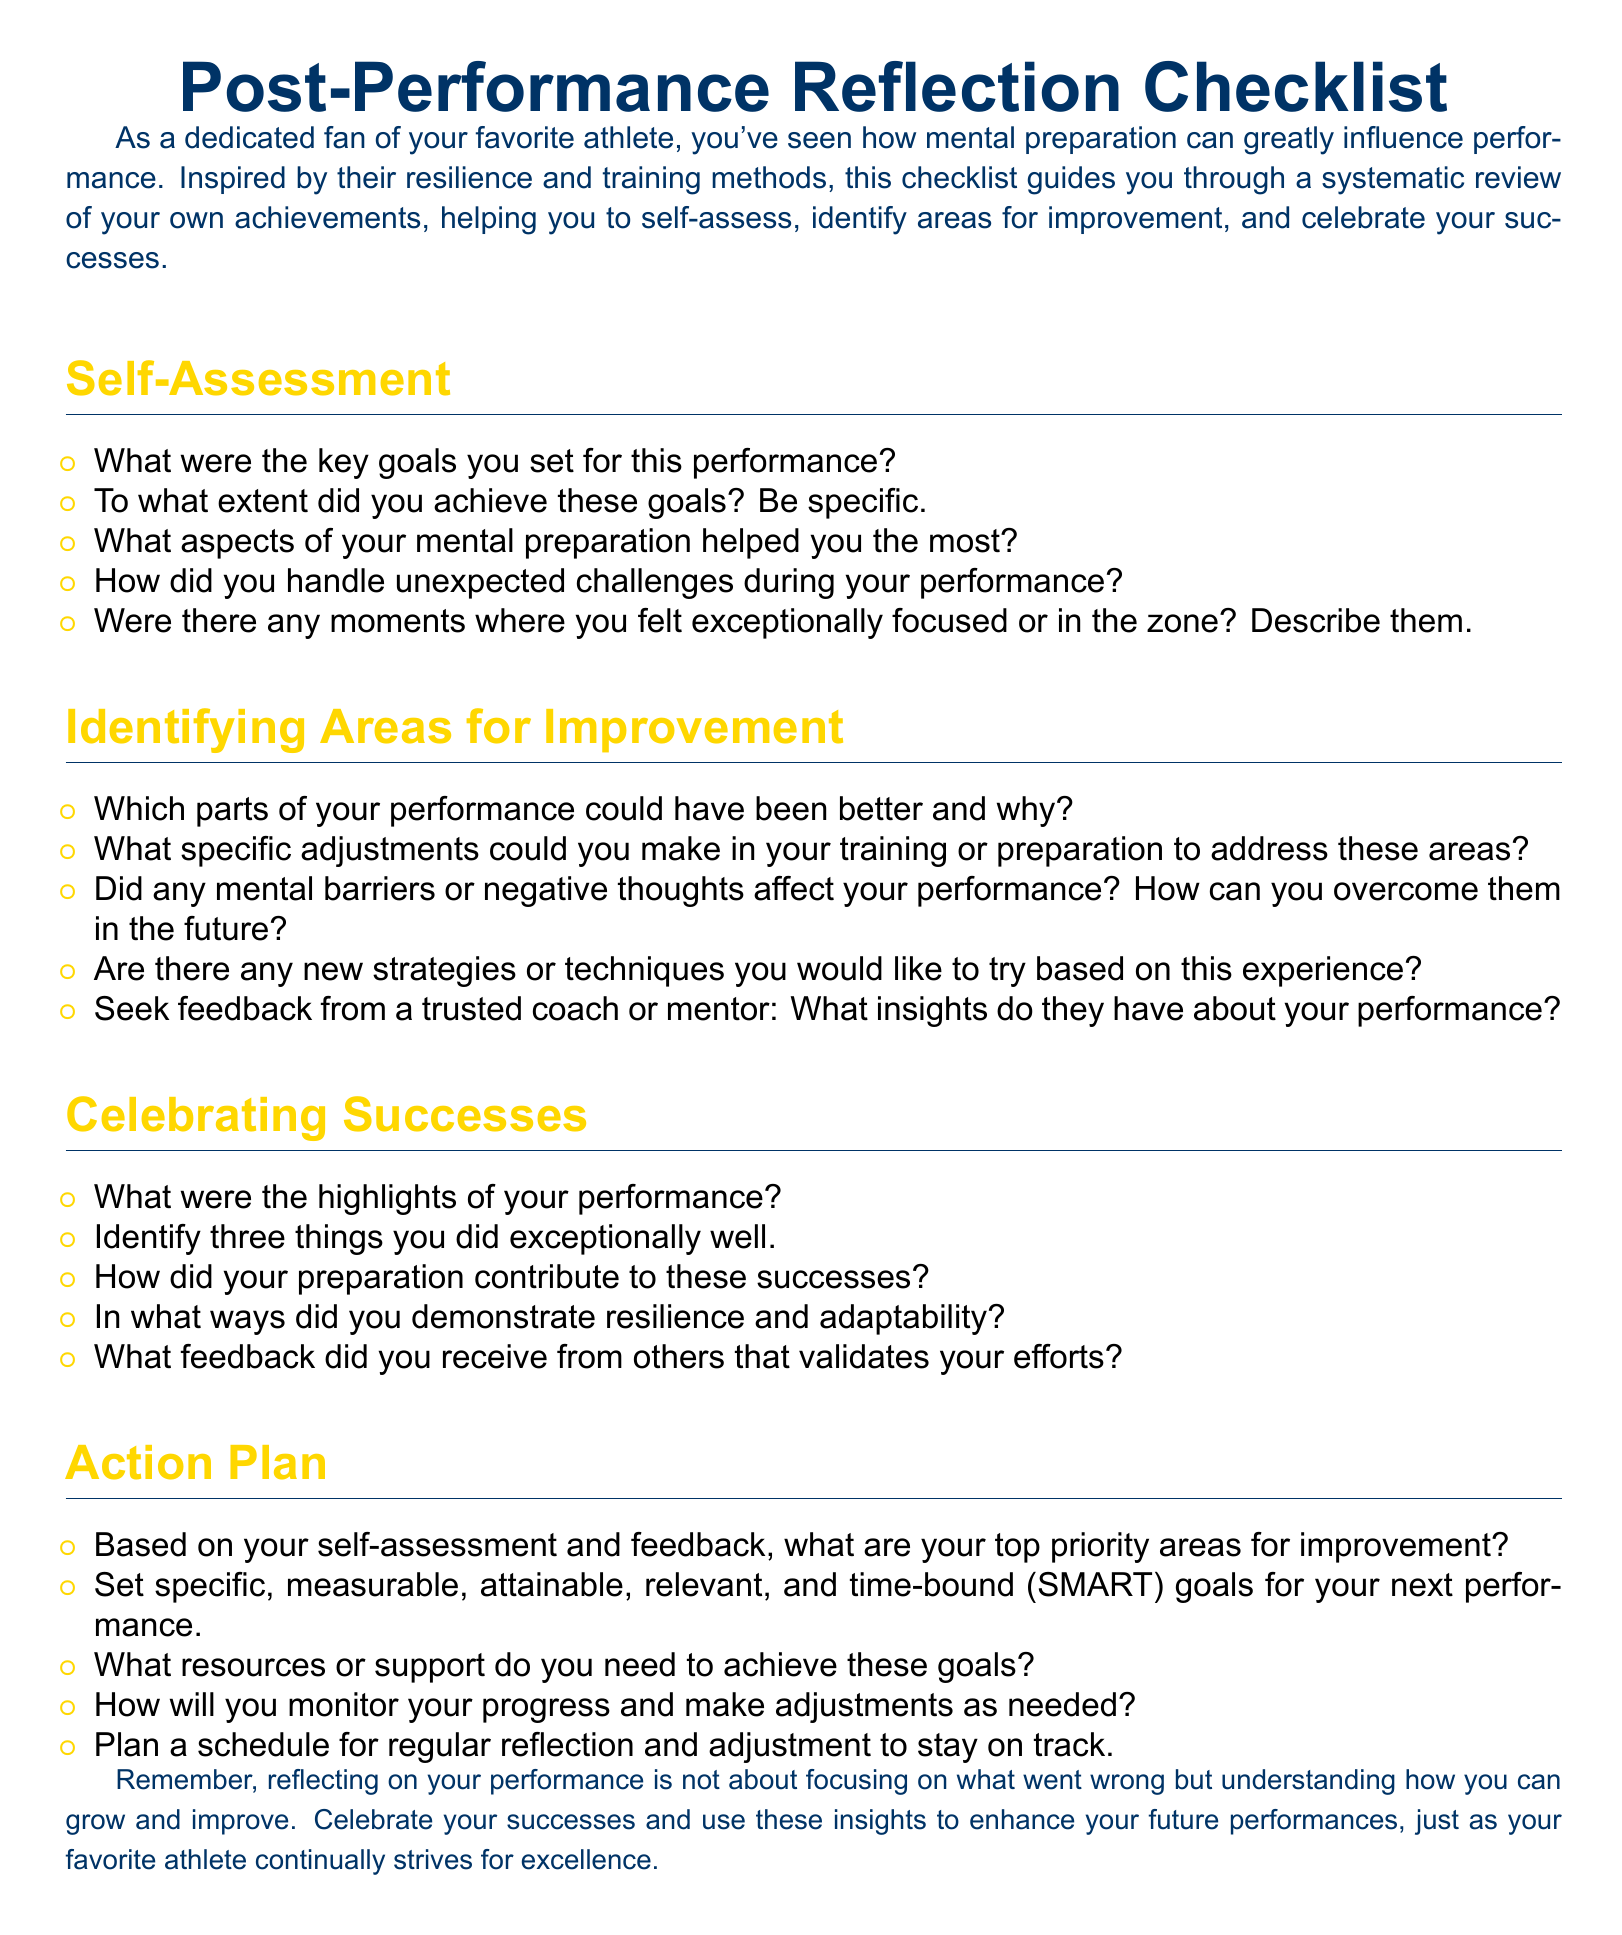What are the three main sections of the checklist? The checklist is divided into sections that focus on different aspects of post-performance reflection: Self-Assessment, Identifying Areas for Improvement, and Celebrating Successes.
Answer: Self-Assessment, Identifying Areas for Improvement, Celebrating Successes What color is used for the section titles? The section titles are colored deep blue, as stated in the document.
Answer: Deep blue How many prompts are in the Self-Assessment section? The Self-Assessment section contains five prompts for reflection, as listed in the document.
Answer: Five Which prompt focuses on mental barriers? The prompt related to mental barriers asks about negative thoughts that affected performance, seeking ways to overcome them.
Answer: Did any mental barriers or negative thoughts affect your performance? How can you overcome them in the future? What type of goals are suggested in the Action Plan? The Action Plan suggests setting goals that are specific, measurable, attainable, relevant, and time-bound (SMART).
Answer: SMART What does the document encourage following reflection? The document emphasizes the importance of recognizing successes and learning from experiences to enhance future performances.
Answer: Celebrate your successes and use these insights to enhance your future performances 